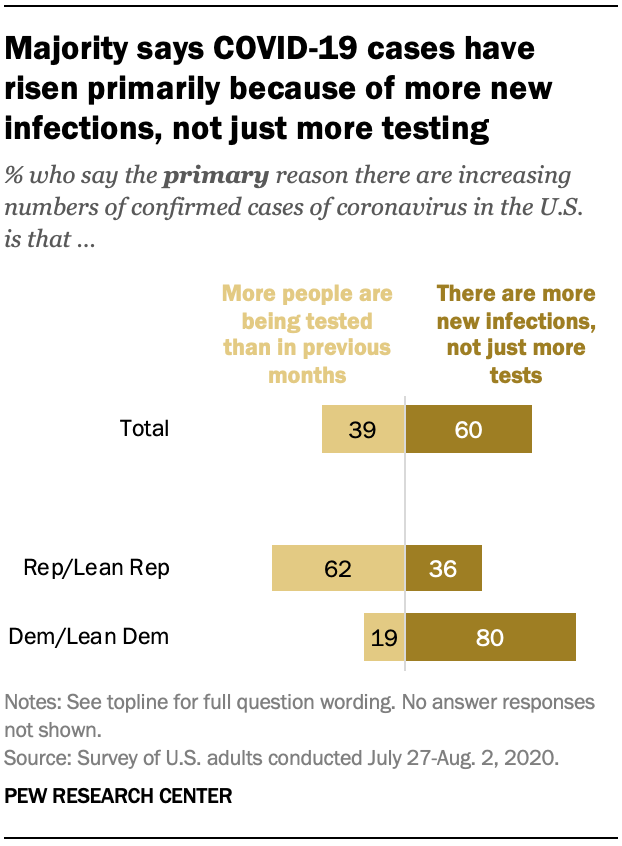Identify some key points in this picture. The missing data is 39, 62, and there is an unknown value. The ratio of the largest bar and the dark brown bar in the Total category is 0.16875, and that is the value that we want to calculate. 